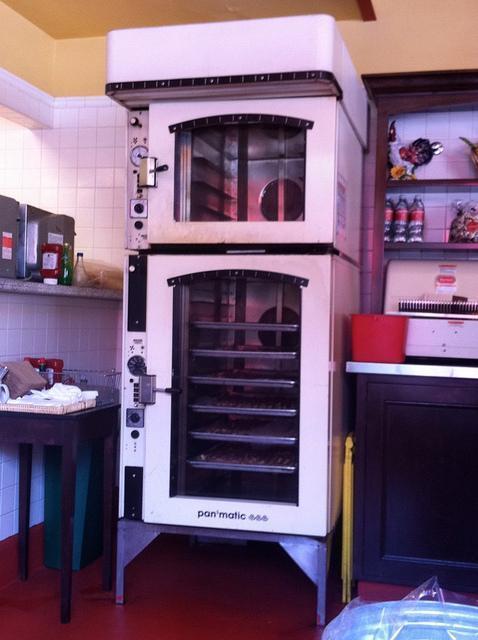How many ovens are there?
Give a very brief answer. 2. 